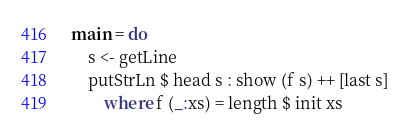Convert code to text. <code><loc_0><loc_0><loc_500><loc_500><_Haskell_>main = do
	s <- getLine
	putStrLn $ head s : show (f s) ++ [last s]
		where f (_:xs) = length $ init xs</code> 